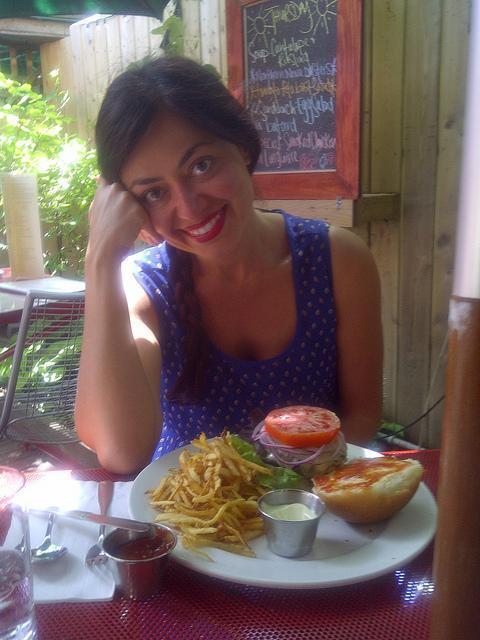How many cups are there?
Give a very brief answer. 3. 